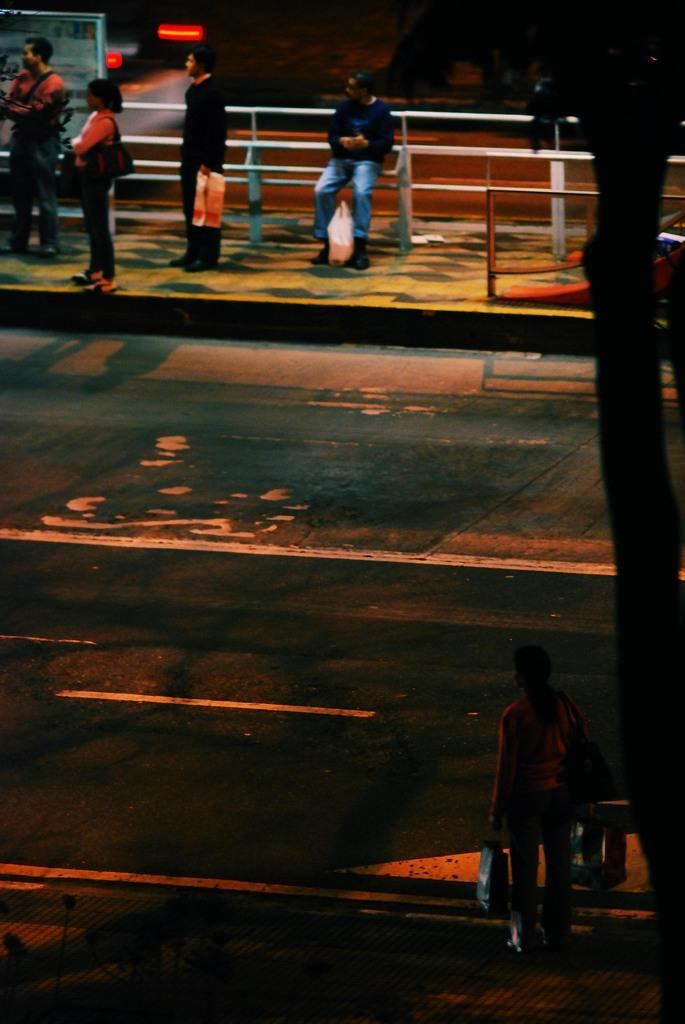How many people are in the image? There are people in the image, but the exact number is not specified. What can be seen near the people in the image? There is a railing in the image. What other objects can be seen in the image? There is a board, a road, a tree, and unspecified objects in the image. What type of wine is being served at the back of the image? There is no wine present in the image, and the term "back" is not relevant to the image's content. 